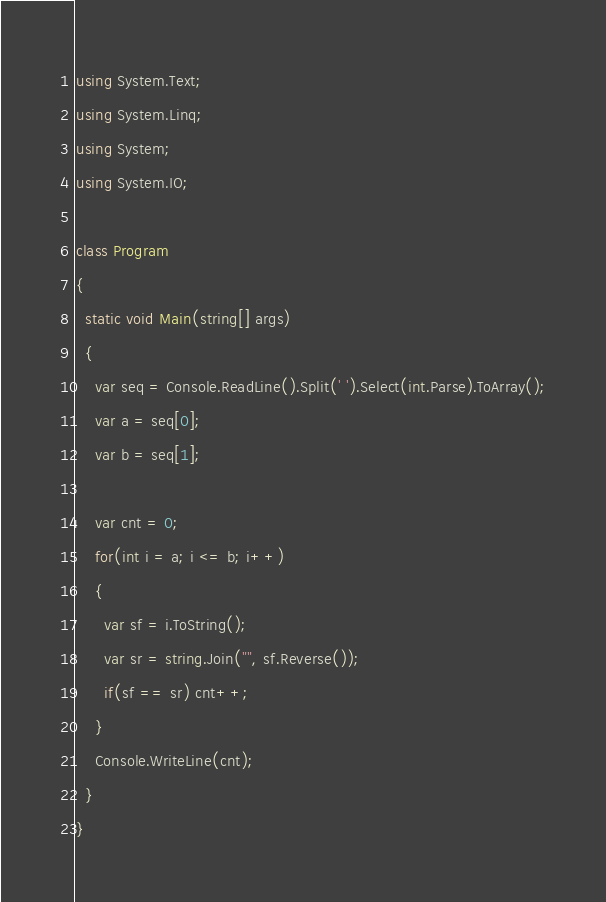<code> <loc_0><loc_0><loc_500><loc_500><_C#_>using System.Text;
using System.Linq;
using System;
using System.IO;

class Program
{
  static void Main(string[] args)
  {
    var seq = Console.ReadLine().Split(' ').Select(int.Parse).ToArray();
    var a = seq[0];
    var b = seq[1];

    var cnt = 0;
    for(int i = a; i <= b; i++)
    {
      var sf = i.ToString();
      var sr = string.Join("", sf.Reverse());
      if(sf == sr) cnt++;
    }
    Console.WriteLine(cnt);
  }
}</code> 